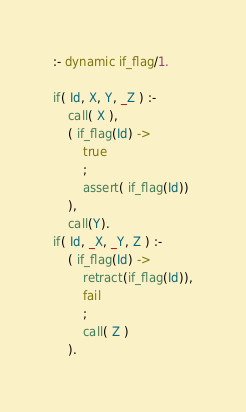<code> <loc_0><loc_0><loc_500><loc_500><_Prolog_>:- dynamic if_flag/1.

if( Id, X, Y, _Z ) :- 
	call( X ),
	( if_flag(Id) -> 
		true
		;
		assert( if_flag(Id)) 
	),
	call(Y).
if( Id, _X, _Y, Z ) :- 
	( if_flag(Id) -> 
		retract(if_flag(Id)),
		fail
		;
		call( Z )
	).
</code> 